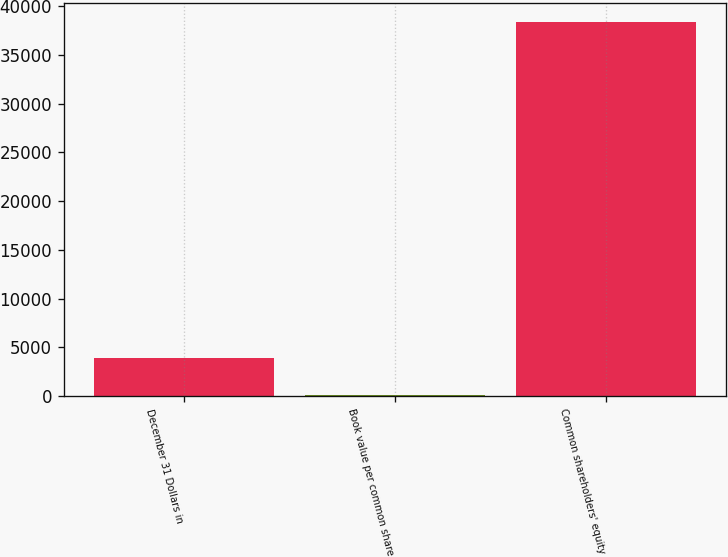Convert chart to OTSL. <chart><loc_0><loc_0><loc_500><loc_500><bar_chart><fcel>December 31 Dollars in<fcel>Book value per common share<fcel>Common shareholders' equity<nl><fcel>3904.06<fcel>72.07<fcel>38392<nl></chart> 